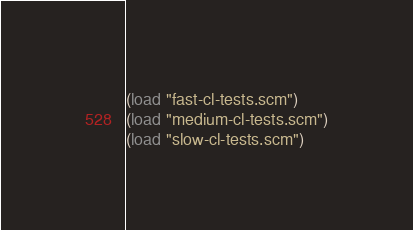Convert code to text. <code><loc_0><loc_0><loc_500><loc_500><_Scheme_>(load "fast-cl-tests.scm")
(load "medium-cl-tests.scm")
(load "slow-cl-tests.scm")
</code> 